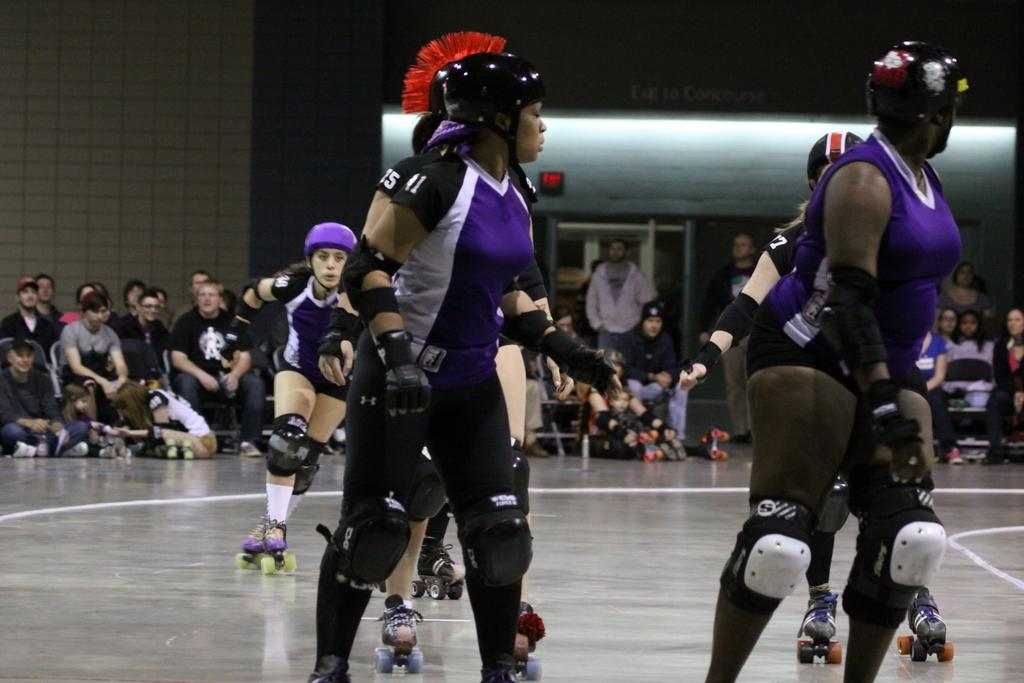What activity are the people in the center of the image engaged in? The people in the center of the image are skating. What safety equipment are the skaters wearing? The people skating are wearing helmets. What can be seen in the background of the image? There is a wall and people sitting in the background of the image. What type of thunder can be heard in the image? There is no sound present in the image, so it is not possible to determine if there is any thunder. 